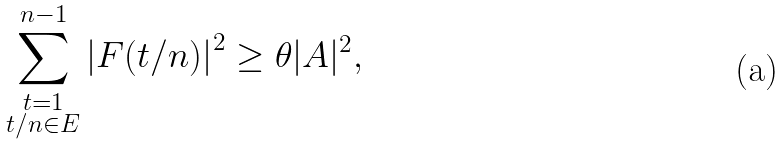Convert formula to latex. <formula><loc_0><loc_0><loc_500><loc_500>\sum _ { \substack { t = 1 \\ t / n \in E } } ^ { n - 1 } \left | F ( t / n ) \right | ^ { 2 } \geq \theta | A | ^ { 2 } ,</formula> 